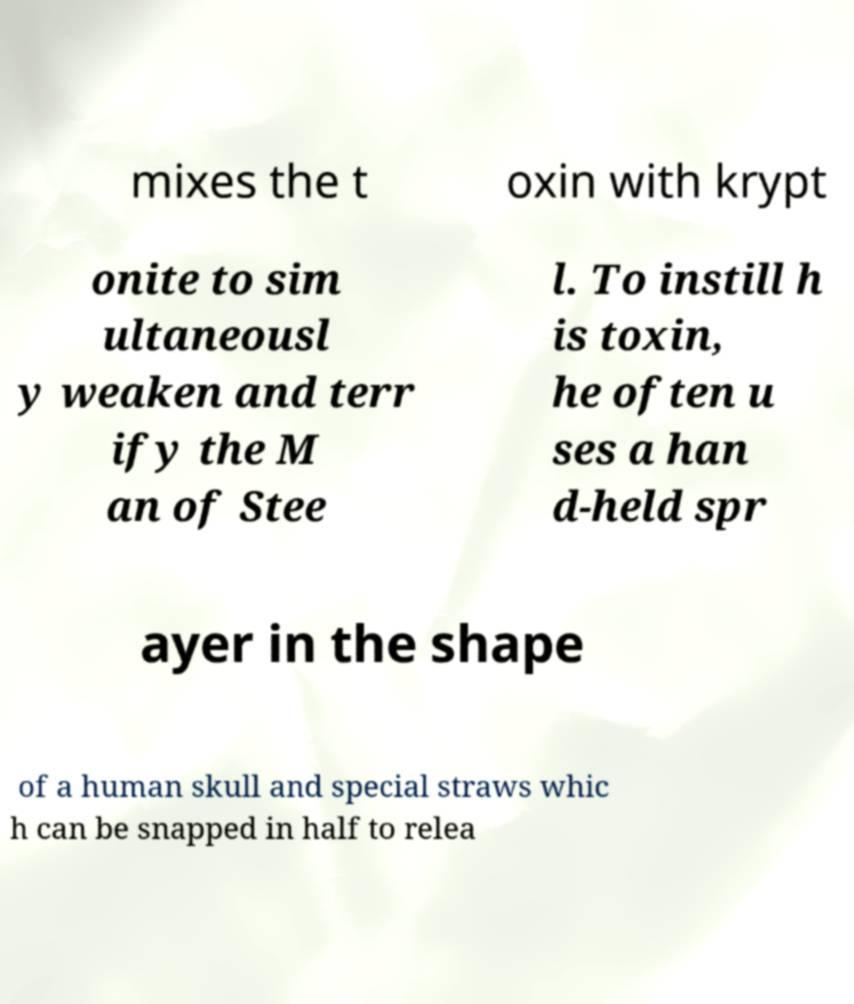Can you accurately transcribe the text from the provided image for me? mixes the t oxin with krypt onite to sim ultaneousl y weaken and terr ify the M an of Stee l. To instill h is toxin, he often u ses a han d-held spr ayer in the shape of a human skull and special straws whic h can be snapped in half to relea 